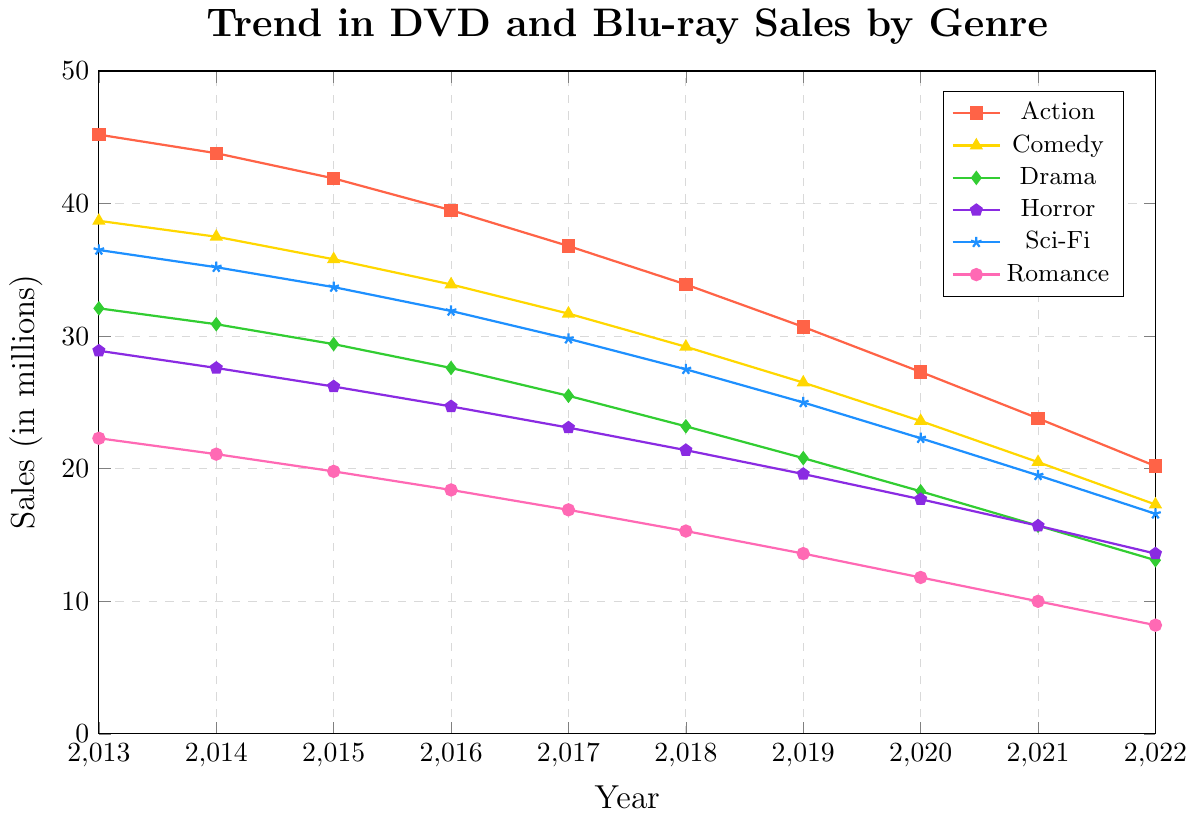Which genre had the highest sales in 2013? By looking at the values for 2013, Action had the highest sales at 45.2 million.
Answer: Action Which genre had the least decline in sales from 2013 to 2022? Calculating the difference for each genre from 2013 to 2022 and comparing: 
- Action: 45.2 - 20.2 = 25.0 
- Comedy: 38.7 - 17.3 = 21.4
- Drama: 32.1 - 13.1 = 19.0 
- Horror: 28.9 - 13.6 = 15.3 
- Sci-Fi: 36.5 - 16.6 = 19.9 
- Romance: 22.3 - 8.2 = 14.1 
Romance had the least decline.
Answer: Romance In which year did Horror genre sales fall below 20 million? Looking at the Horror data, sales fell below 20 million in 2019.
Answer: 2019 Which genre showed the most consistent decline year-over-year? Examining the trend, all genres showed consistent declines, but Horror and Romance had similar, small decreases each year.
Answer: Romance and Horror What is the total sales for all genres combined in 2018? Summing the sales for each genre in 2018: 33.9 (Action) + 29.2 (Comedy) + 23.2 (Drama) + 21.4 (Horror) + 27.5 (Sci-Fi) + 15.3 (Romance) = 150.5 million.
Answer: 150.5 Which genre had a greater decline in sales, Sci-Fi or Comedy, from 2013 to 2022? Calculating the decline: 
- Sci-Fi: 36.5 - 16.6 = 19.9 
- Comedy: 38.7 - 17.3 = 21.4 
Comedy had a greater decline.
Answer: Comedy By what percentage did Action sales decline from 2013 to 2022? Calculating percentage decline: 
((45.2 - 20.2)/45.2) * 100 ≈ 55.3%.
Answer: Approximately 55.3% In which year did Action genre dip below 30 million sales? By looking at the Action data, it fell below 30 million in 2019.
Answer: 2019 What is the difference in sales between the highest and lowest selling genres in 2022? In 2022, the highest sales were in Action (20.2) and the lowest in Romance (8.2), so the difference is 20.2 - 8.2 = 12 million.
Answer: 12 